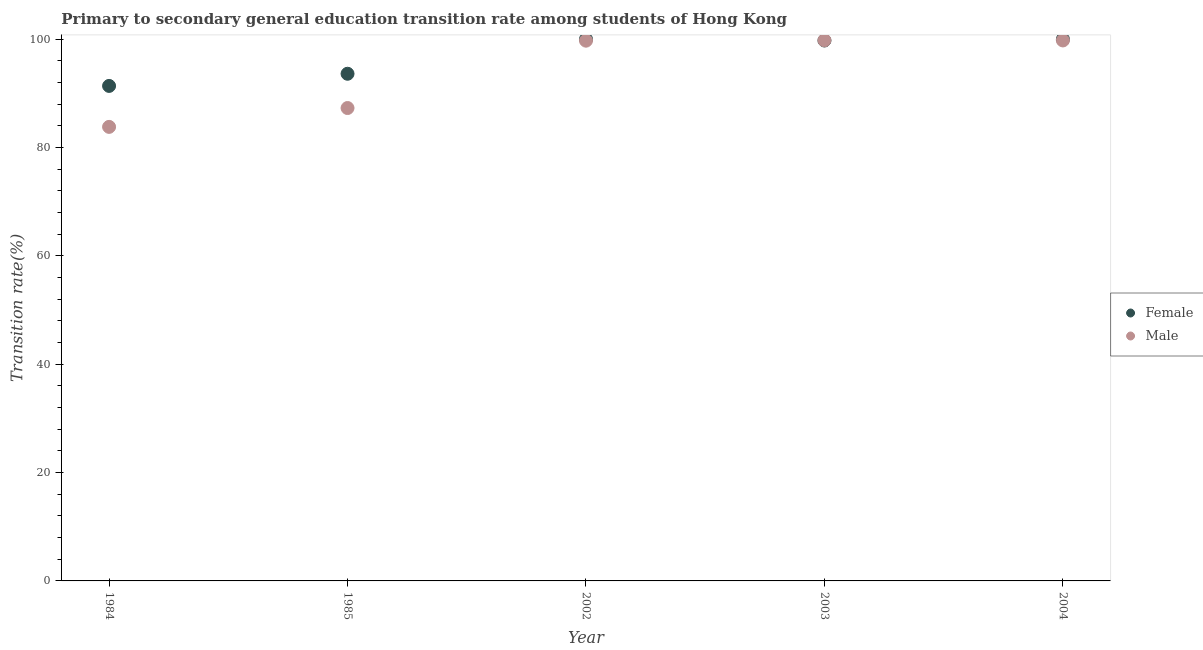What is the transition rate among female students in 2004?
Provide a succinct answer. 100. Across all years, what is the maximum transition rate among male students?
Keep it short and to the point. 99.81. Across all years, what is the minimum transition rate among female students?
Ensure brevity in your answer.  91.38. What is the total transition rate among male students in the graph?
Your answer should be compact. 470.46. What is the difference between the transition rate among male students in 1984 and that in 2003?
Give a very brief answer. -15.99. What is the difference between the transition rate among female students in 2002 and the transition rate among male students in 2004?
Offer a very short reply. 0.22. What is the average transition rate among female students per year?
Offer a very short reply. 96.96. In the year 2003, what is the difference between the transition rate among female students and transition rate among male students?
Ensure brevity in your answer.  -0.04. What is the ratio of the transition rate among male students in 1984 to that in 2004?
Offer a very short reply. 0.84. Is the transition rate among female students in 1984 less than that in 2002?
Give a very brief answer. Yes. Is the difference between the transition rate among male students in 1985 and 2003 greater than the difference between the transition rate among female students in 1985 and 2003?
Provide a short and direct response. No. What is the difference between the highest and the second highest transition rate among male students?
Provide a succinct answer. 0.03. What is the difference between the highest and the lowest transition rate among male students?
Provide a succinct answer. 15.99. In how many years, is the transition rate among male students greater than the average transition rate among male students taken over all years?
Your response must be concise. 3. Does the transition rate among female students monotonically increase over the years?
Your answer should be compact. No. Is the transition rate among female students strictly greater than the transition rate among male students over the years?
Offer a terse response. No. Does the graph contain grids?
Offer a very short reply. No. How many legend labels are there?
Keep it short and to the point. 2. How are the legend labels stacked?
Provide a succinct answer. Vertical. What is the title of the graph?
Offer a very short reply. Primary to secondary general education transition rate among students of Hong Kong. What is the label or title of the X-axis?
Provide a succinct answer. Year. What is the label or title of the Y-axis?
Your answer should be compact. Transition rate(%). What is the Transition rate(%) in Female in 1984?
Your answer should be very brief. 91.38. What is the Transition rate(%) in Male in 1984?
Make the answer very short. 83.82. What is the Transition rate(%) of Female in 1985?
Offer a very short reply. 93.63. What is the Transition rate(%) of Male in 1985?
Keep it short and to the point. 87.3. What is the Transition rate(%) in Male in 2002?
Ensure brevity in your answer.  99.74. What is the Transition rate(%) in Female in 2003?
Ensure brevity in your answer.  99.77. What is the Transition rate(%) of Male in 2003?
Provide a short and direct response. 99.81. What is the Transition rate(%) of Female in 2004?
Provide a short and direct response. 100. What is the Transition rate(%) in Male in 2004?
Your answer should be compact. 99.78. Across all years, what is the maximum Transition rate(%) in Female?
Ensure brevity in your answer.  100. Across all years, what is the maximum Transition rate(%) of Male?
Provide a short and direct response. 99.81. Across all years, what is the minimum Transition rate(%) in Female?
Your answer should be very brief. 91.38. Across all years, what is the minimum Transition rate(%) in Male?
Provide a succinct answer. 83.82. What is the total Transition rate(%) of Female in the graph?
Ensure brevity in your answer.  484.78. What is the total Transition rate(%) of Male in the graph?
Your answer should be compact. 470.46. What is the difference between the Transition rate(%) of Female in 1984 and that in 1985?
Keep it short and to the point. -2.25. What is the difference between the Transition rate(%) of Male in 1984 and that in 1985?
Keep it short and to the point. -3.48. What is the difference between the Transition rate(%) of Female in 1984 and that in 2002?
Provide a succinct answer. -8.62. What is the difference between the Transition rate(%) of Male in 1984 and that in 2002?
Your answer should be compact. -15.91. What is the difference between the Transition rate(%) in Female in 1984 and that in 2003?
Keep it short and to the point. -8.38. What is the difference between the Transition rate(%) of Male in 1984 and that in 2003?
Make the answer very short. -15.99. What is the difference between the Transition rate(%) of Female in 1984 and that in 2004?
Provide a short and direct response. -8.62. What is the difference between the Transition rate(%) in Male in 1984 and that in 2004?
Offer a terse response. -15.96. What is the difference between the Transition rate(%) of Female in 1985 and that in 2002?
Provide a short and direct response. -6.37. What is the difference between the Transition rate(%) of Male in 1985 and that in 2002?
Provide a short and direct response. -12.43. What is the difference between the Transition rate(%) in Female in 1985 and that in 2003?
Your answer should be compact. -6.14. What is the difference between the Transition rate(%) of Male in 1985 and that in 2003?
Make the answer very short. -12.51. What is the difference between the Transition rate(%) in Female in 1985 and that in 2004?
Offer a very short reply. -6.37. What is the difference between the Transition rate(%) in Male in 1985 and that in 2004?
Offer a very short reply. -12.48. What is the difference between the Transition rate(%) in Female in 2002 and that in 2003?
Your answer should be compact. 0.23. What is the difference between the Transition rate(%) in Male in 2002 and that in 2003?
Provide a short and direct response. -0.07. What is the difference between the Transition rate(%) of Male in 2002 and that in 2004?
Ensure brevity in your answer.  -0.04. What is the difference between the Transition rate(%) in Female in 2003 and that in 2004?
Offer a terse response. -0.23. What is the difference between the Transition rate(%) in Male in 2003 and that in 2004?
Offer a terse response. 0.03. What is the difference between the Transition rate(%) in Female in 1984 and the Transition rate(%) in Male in 1985?
Make the answer very short. 4.08. What is the difference between the Transition rate(%) of Female in 1984 and the Transition rate(%) of Male in 2002?
Provide a short and direct response. -8.35. What is the difference between the Transition rate(%) of Female in 1984 and the Transition rate(%) of Male in 2003?
Make the answer very short. -8.43. What is the difference between the Transition rate(%) in Female in 1984 and the Transition rate(%) in Male in 2004?
Provide a short and direct response. -8.4. What is the difference between the Transition rate(%) of Female in 1985 and the Transition rate(%) of Male in 2002?
Give a very brief answer. -6.11. What is the difference between the Transition rate(%) of Female in 1985 and the Transition rate(%) of Male in 2003?
Your answer should be very brief. -6.18. What is the difference between the Transition rate(%) in Female in 1985 and the Transition rate(%) in Male in 2004?
Your response must be concise. -6.15. What is the difference between the Transition rate(%) in Female in 2002 and the Transition rate(%) in Male in 2003?
Provide a succinct answer. 0.19. What is the difference between the Transition rate(%) in Female in 2002 and the Transition rate(%) in Male in 2004?
Your response must be concise. 0.22. What is the difference between the Transition rate(%) in Female in 2003 and the Transition rate(%) in Male in 2004?
Your answer should be very brief. -0.01. What is the average Transition rate(%) in Female per year?
Offer a very short reply. 96.96. What is the average Transition rate(%) in Male per year?
Keep it short and to the point. 94.09. In the year 1984, what is the difference between the Transition rate(%) in Female and Transition rate(%) in Male?
Make the answer very short. 7.56. In the year 1985, what is the difference between the Transition rate(%) of Female and Transition rate(%) of Male?
Your answer should be very brief. 6.33. In the year 2002, what is the difference between the Transition rate(%) in Female and Transition rate(%) in Male?
Your response must be concise. 0.26. In the year 2003, what is the difference between the Transition rate(%) of Female and Transition rate(%) of Male?
Provide a succinct answer. -0.04. In the year 2004, what is the difference between the Transition rate(%) of Female and Transition rate(%) of Male?
Ensure brevity in your answer.  0.22. What is the ratio of the Transition rate(%) in Female in 1984 to that in 1985?
Give a very brief answer. 0.98. What is the ratio of the Transition rate(%) in Male in 1984 to that in 1985?
Ensure brevity in your answer.  0.96. What is the ratio of the Transition rate(%) in Female in 1984 to that in 2002?
Give a very brief answer. 0.91. What is the ratio of the Transition rate(%) in Male in 1984 to that in 2002?
Offer a very short reply. 0.84. What is the ratio of the Transition rate(%) in Female in 1984 to that in 2003?
Your response must be concise. 0.92. What is the ratio of the Transition rate(%) of Male in 1984 to that in 2003?
Give a very brief answer. 0.84. What is the ratio of the Transition rate(%) in Female in 1984 to that in 2004?
Offer a very short reply. 0.91. What is the ratio of the Transition rate(%) of Male in 1984 to that in 2004?
Provide a short and direct response. 0.84. What is the ratio of the Transition rate(%) in Female in 1985 to that in 2002?
Keep it short and to the point. 0.94. What is the ratio of the Transition rate(%) of Male in 1985 to that in 2002?
Ensure brevity in your answer.  0.88. What is the ratio of the Transition rate(%) of Female in 1985 to that in 2003?
Ensure brevity in your answer.  0.94. What is the ratio of the Transition rate(%) of Male in 1985 to that in 2003?
Ensure brevity in your answer.  0.87. What is the ratio of the Transition rate(%) in Female in 1985 to that in 2004?
Keep it short and to the point. 0.94. What is the ratio of the Transition rate(%) of Male in 1985 to that in 2004?
Make the answer very short. 0.87. What is the ratio of the Transition rate(%) of Female in 2002 to that in 2004?
Provide a succinct answer. 1. What is the ratio of the Transition rate(%) of Male in 2002 to that in 2004?
Offer a terse response. 1. What is the ratio of the Transition rate(%) of Female in 2003 to that in 2004?
Your answer should be compact. 1. What is the ratio of the Transition rate(%) of Male in 2003 to that in 2004?
Provide a short and direct response. 1. What is the difference between the highest and the second highest Transition rate(%) in Male?
Keep it short and to the point. 0.03. What is the difference between the highest and the lowest Transition rate(%) of Female?
Your answer should be very brief. 8.62. What is the difference between the highest and the lowest Transition rate(%) of Male?
Keep it short and to the point. 15.99. 